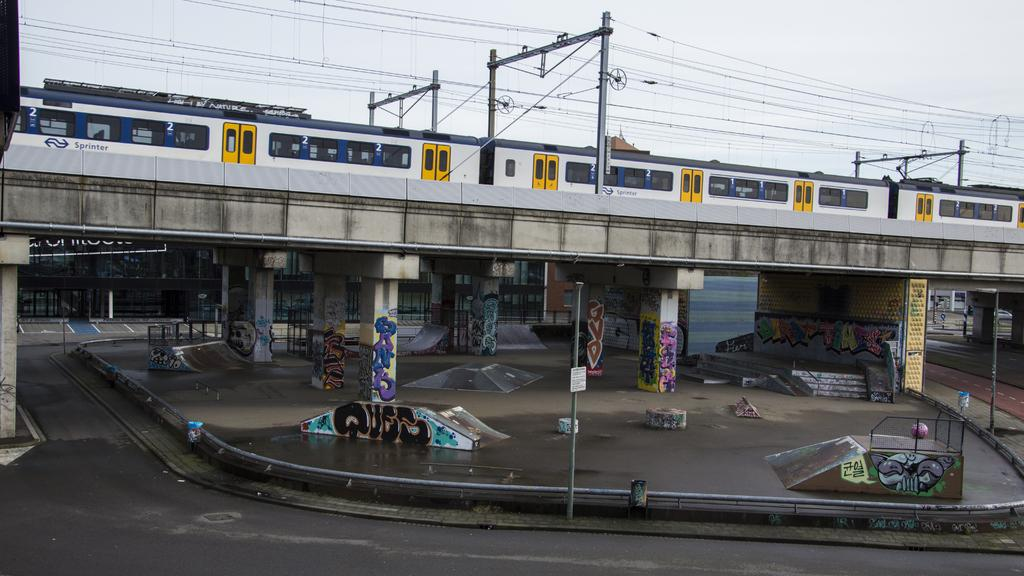What type of transportation can be seen in the image? A train is present on the bridge in the image. What structures are visible in the image? There is a road, a bridge, poles and cables, and pillars in the image. What is the sky's condition in the image? The sky is visible at the top of the image. How many mice are running along the poles in the image? There are no mice present in the image; it features a road, a bridge, a train, poles and cables, and pillars. What type of partner is shown working with the train in the image? There is no partner present in the image; it only shows a train on a bridge. 